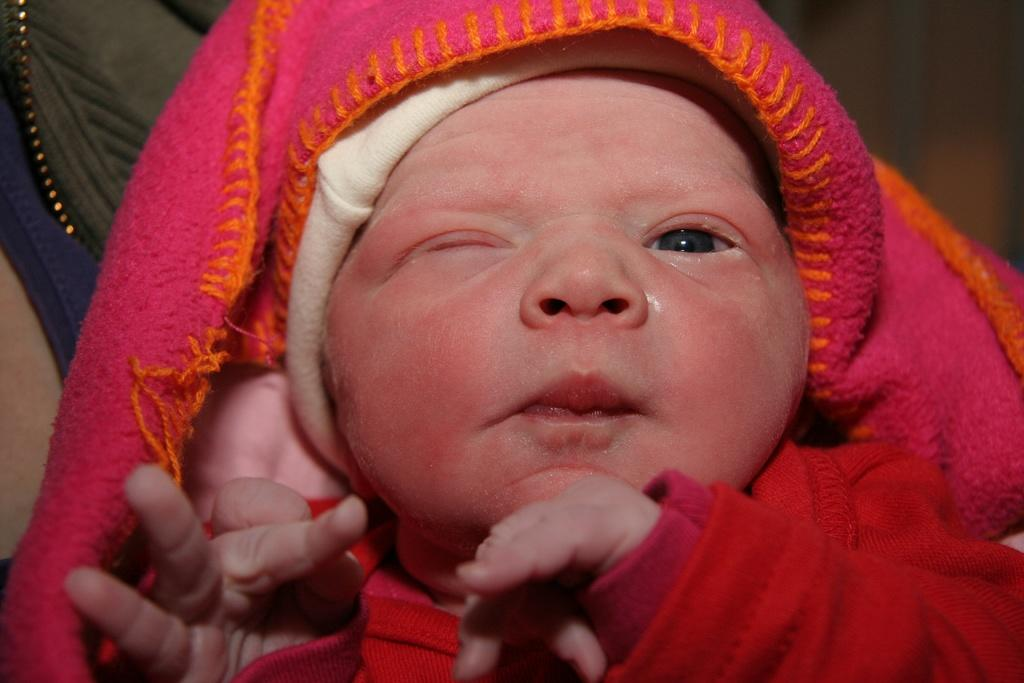What is the main subject in the foreground of the image? There is a baby in the foreground of the image. What is the baby's position in relation to the person carrying them? The baby is being carried by a person. Can you describe the baby's facial expression or appearance? The baby has one eye closed. What type of ball is being used to support the building in the image? There is no ball or building present in the image; it features a baby being carried by a person. 